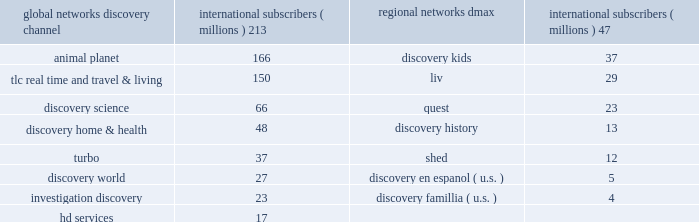Our digital media business consists of our websites and mobile and video-on-demand ( 201cvod 201d ) services .
Our websites include network branded websites such as discovery.com , tlc.com and animalplanet.com , and other websites such as howstuffworks.com , an online source of explanations of how the world actually works ; treehugger.com , a comprehensive source for 201cgreen 201d news , solutions and product information ; and petfinder.com , a leading pet adoption destination .
Together , these websites attracted an average of 24 million cumulative unique monthly visitors , according to comscore , inc .
In 2011 .
International networks our international networks segment principally consists of national and pan-regional television networks .
This segment generates revenues primarily from fees charged to operators who distribute our networks , which primarily include cable and dth satellite service providers , and from advertising sold on our television networks and websites .
Discovery channel , animal planet and tlc lead the international networks 2019 portfolio of television networks , which are distributed in virtually every pay-television market in the world through an infrastructure that includes operational centers in london , singapore and miami .
International networks has one of the largest international distribution platforms of networks with one to twelve networks in more than 200 countries and territories around the world .
At december 31 , 2011 , international networks operated over 150 unique distribution feeds in over 40 languages with channel feeds customized according to language needs and advertising sales opportunities .
Our international networks segment owns and operates the following television networks which reached the following number of subscribers as of december 31 , 2011 : education and other our education and other segment primarily includes the sale of curriculum-based product and service offerings and postproduction audio services .
This segment generates revenues primarily from subscriptions charged to k-12 schools for access to an online suite of curriculum-based vod tools , professional development services , and to a lesser extent student assessment and publication of hardcopy curriculum-based content .
Our education business also participates in corporate partnerships , global brand and content licensing business with leading non-profits , foundations and trade associations .
Other businesses primarily include postproduction audio services that are provided to major motion picture studios , independent producers , broadcast networks , cable channels , advertising agencies , and interactive producers .
Content development our content development strategy is designed to increase viewership , maintain innovation and quality leadership , and provide value for our network distributors and advertising customers .
Substantially all content is sourced from a wide range of third-party producers , which includes some of the world 2019s leading nonfiction production companies with which we have developed long-standing relationships , as well as independent producers .
Our production arrangements fall into three categories : produced , coproduced and licensed .
Substantially all produced content includes programming which we engage third parties to develop and produce while we retain editorial control and own most or all of the rights in exchange for paying all development and production costs .
Coproduced content refers to program rights acquired that we have collaborated with third parties to finance and develop .
Coproduced programs are typically high-cost projects for which neither we nor our coproducers wish to bear the entire cost or productions in which the producer has already taken on an international broadcast partner .
Licensed content is comprised of films or series that have been previously produced by third parties .
Global networks international subscribers ( millions ) regional networks international subscribers ( millions ) .

What's the total in millions for subscribers for the largest 2 regional networks? 
Computations: (213 + 166)
Answer: 379.0. 